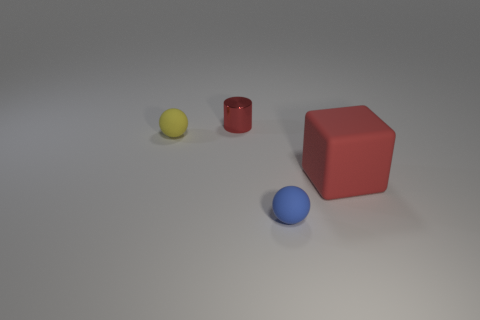Add 4 rubber cubes. How many objects exist? 8 Subtract all cylinders. How many objects are left? 3 Subtract all green cylinders. How many brown spheres are left? 0 Subtract all tiny brown cubes. Subtract all large red matte blocks. How many objects are left? 3 Add 4 tiny rubber things. How many tiny rubber things are left? 6 Add 2 purple matte balls. How many purple matte balls exist? 2 Subtract all blue balls. How many balls are left? 1 Subtract 0 brown spheres. How many objects are left? 4 Subtract 1 balls. How many balls are left? 1 Subtract all purple blocks. Subtract all brown cylinders. How many blocks are left? 1 